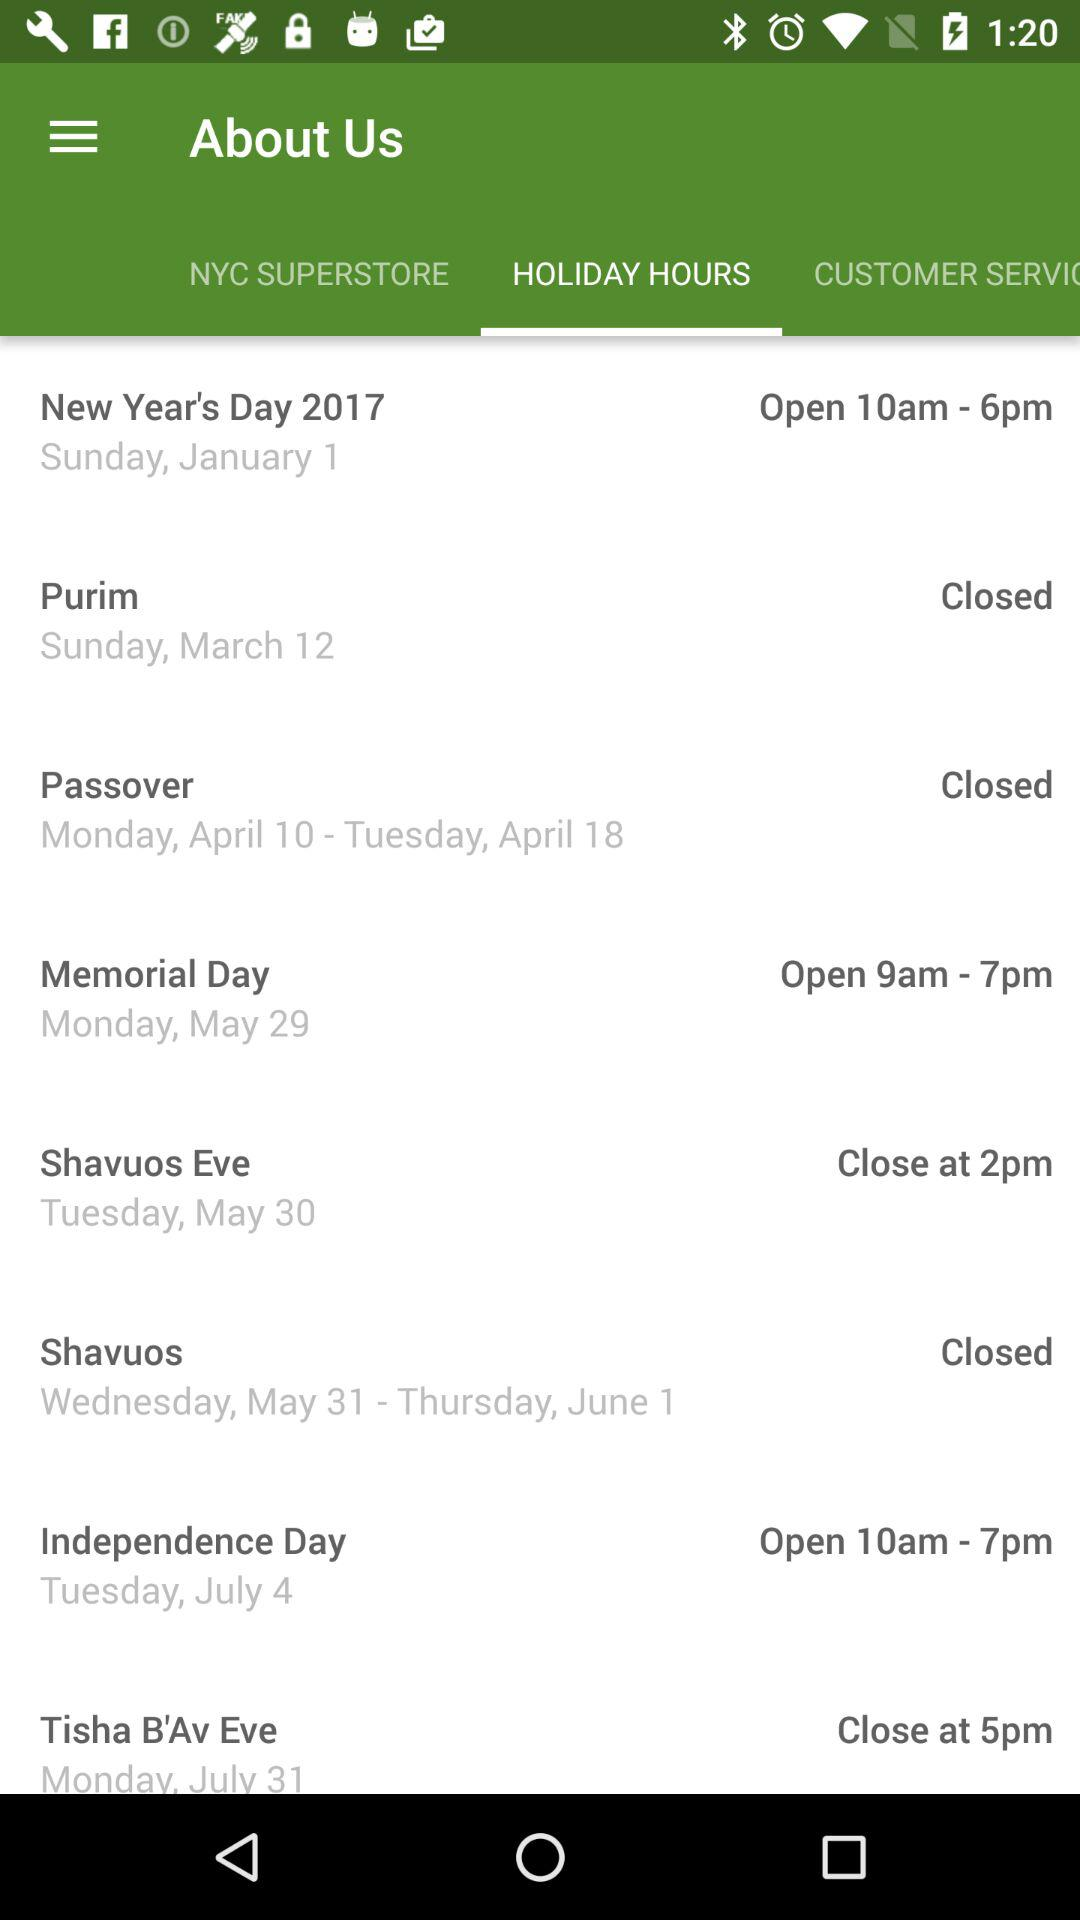What is the opening time on 1 January 2017? The opening time on 1 January 2017 is 10 a.m. 